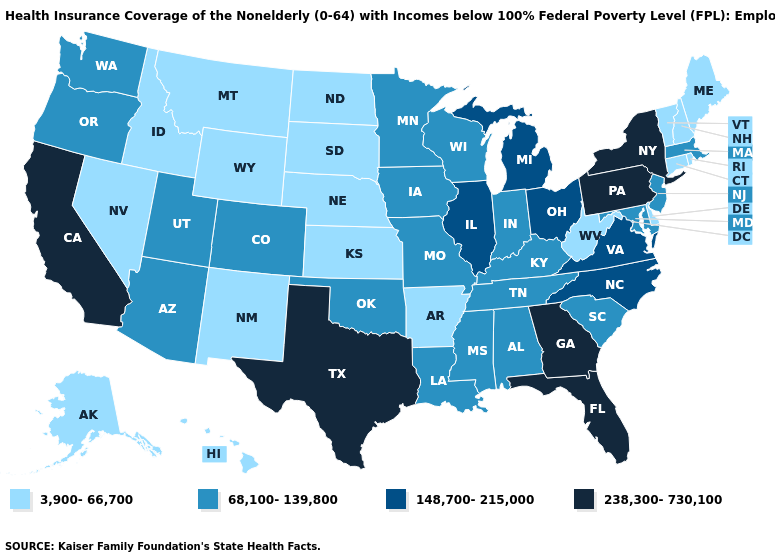Does Maryland have a higher value than Wyoming?
Concise answer only. Yes. What is the value of Michigan?
Give a very brief answer. 148,700-215,000. Which states hav the highest value in the MidWest?
Answer briefly. Illinois, Michigan, Ohio. Does West Virginia have the lowest value in the South?
Concise answer only. Yes. What is the value of Minnesota?
Short answer required. 68,100-139,800. What is the lowest value in states that border Iowa?
Answer briefly. 3,900-66,700. Name the states that have a value in the range 148,700-215,000?
Be succinct. Illinois, Michigan, North Carolina, Ohio, Virginia. Does Vermont have the highest value in the USA?
Concise answer only. No. What is the value of Nevada?
Answer briefly. 3,900-66,700. What is the value of West Virginia?
Keep it brief. 3,900-66,700. Among the states that border Maryland , does Pennsylvania have the highest value?
Answer briefly. Yes. Name the states that have a value in the range 68,100-139,800?
Write a very short answer. Alabama, Arizona, Colorado, Indiana, Iowa, Kentucky, Louisiana, Maryland, Massachusetts, Minnesota, Mississippi, Missouri, New Jersey, Oklahoma, Oregon, South Carolina, Tennessee, Utah, Washington, Wisconsin. Name the states that have a value in the range 3,900-66,700?
Short answer required. Alaska, Arkansas, Connecticut, Delaware, Hawaii, Idaho, Kansas, Maine, Montana, Nebraska, Nevada, New Hampshire, New Mexico, North Dakota, Rhode Island, South Dakota, Vermont, West Virginia, Wyoming. Does Georgia have the lowest value in the USA?
Concise answer only. No. Does Wisconsin have the highest value in the MidWest?
Give a very brief answer. No. 